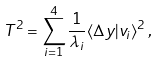<formula> <loc_0><loc_0><loc_500><loc_500>T ^ { 2 } = \sum _ { i = 1 } ^ { 4 } \frac { 1 } { \lambda _ { i } } \langle \Delta y | v _ { i } \rangle ^ { 2 } \, ,</formula> 